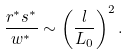<formula> <loc_0><loc_0><loc_500><loc_500>\frac { r ^ { * } s ^ { * } } { w ^ { * } } \sim \left ( \frac { l } { L _ { 0 } } \right ) ^ { 2 } .</formula> 